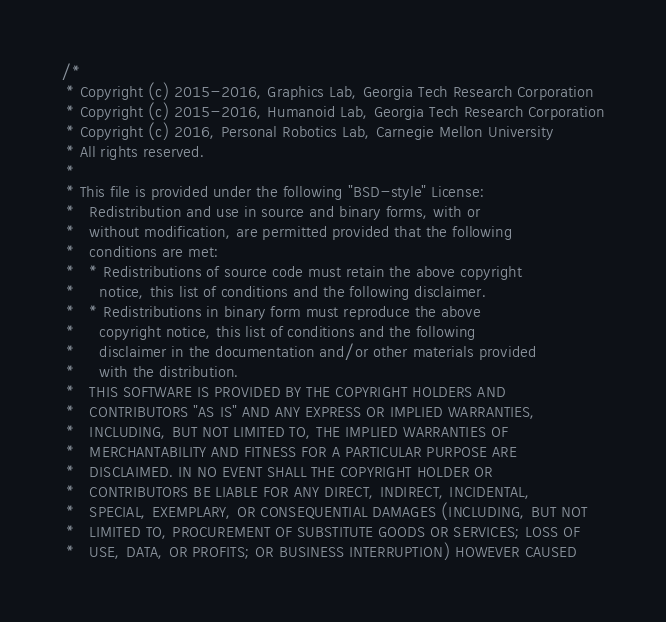Convert code to text. <code><loc_0><loc_0><loc_500><loc_500><_C++_>/*
 * Copyright (c) 2015-2016, Graphics Lab, Georgia Tech Research Corporation
 * Copyright (c) 2015-2016, Humanoid Lab, Georgia Tech Research Corporation
 * Copyright (c) 2016, Personal Robotics Lab, Carnegie Mellon University
 * All rights reserved.
 *
 * This file is provided under the following "BSD-style" License:
 *   Redistribution and use in source and binary forms, with or
 *   without modification, are permitted provided that the following
 *   conditions are met:
 *   * Redistributions of source code must retain the above copyright
 *     notice, this list of conditions and the following disclaimer.
 *   * Redistributions in binary form must reproduce the above
 *     copyright notice, this list of conditions and the following
 *     disclaimer in the documentation and/or other materials provided
 *     with the distribution.
 *   THIS SOFTWARE IS PROVIDED BY THE COPYRIGHT HOLDERS AND
 *   CONTRIBUTORS "AS IS" AND ANY EXPRESS OR IMPLIED WARRANTIES,
 *   INCLUDING, BUT NOT LIMITED TO, THE IMPLIED WARRANTIES OF
 *   MERCHANTABILITY AND FITNESS FOR A PARTICULAR PURPOSE ARE
 *   DISCLAIMED. IN NO EVENT SHALL THE COPYRIGHT HOLDER OR
 *   CONTRIBUTORS BE LIABLE FOR ANY DIRECT, INDIRECT, INCIDENTAL,
 *   SPECIAL, EXEMPLARY, OR CONSEQUENTIAL DAMAGES (INCLUDING, BUT NOT
 *   LIMITED TO, PROCUREMENT OF SUBSTITUTE GOODS OR SERVICES; LOSS OF
 *   USE, DATA, OR PROFITS; OR BUSINESS INTERRUPTION) HOWEVER CAUSED</code> 